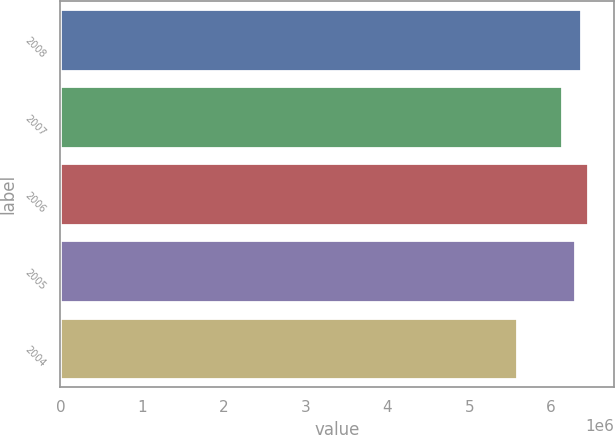Convert chart. <chart><loc_0><loc_0><loc_500><loc_500><bar_chart><fcel>2008<fcel>2007<fcel>2006<fcel>2005<fcel>2004<nl><fcel>6.3681e+06<fcel>6.139e+06<fcel>6.4462e+06<fcel>6.29e+06<fcel>5.589e+06<nl></chart> 